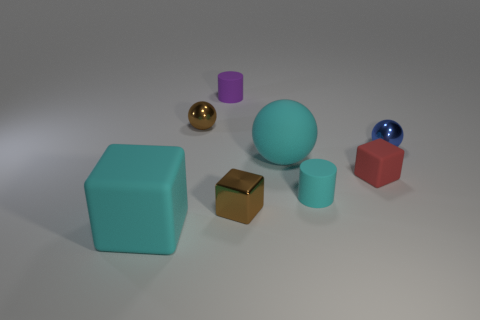Subtract all metal blocks. How many blocks are left? 2 Add 1 cyan spheres. How many objects exist? 9 Subtract all red cubes. How many cubes are left? 2 Subtract all spheres. How many objects are left? 5 Subtract 2 blocks. How many blocks are left? 1 Subtract all cyan cylinders. Subtract all blue cubes. How many cylinders are left? 1 Subtract all cyan cylinders. How many cyan balls are left? 1 Subtract all balls. Subtract all red cubes. How many objects are left? 4 Add 8 cyan rubber spheres. How many cyan rubber spheres are left? 9 Add 6 brown shiny objects. How many brown shiny objects exist? 8 